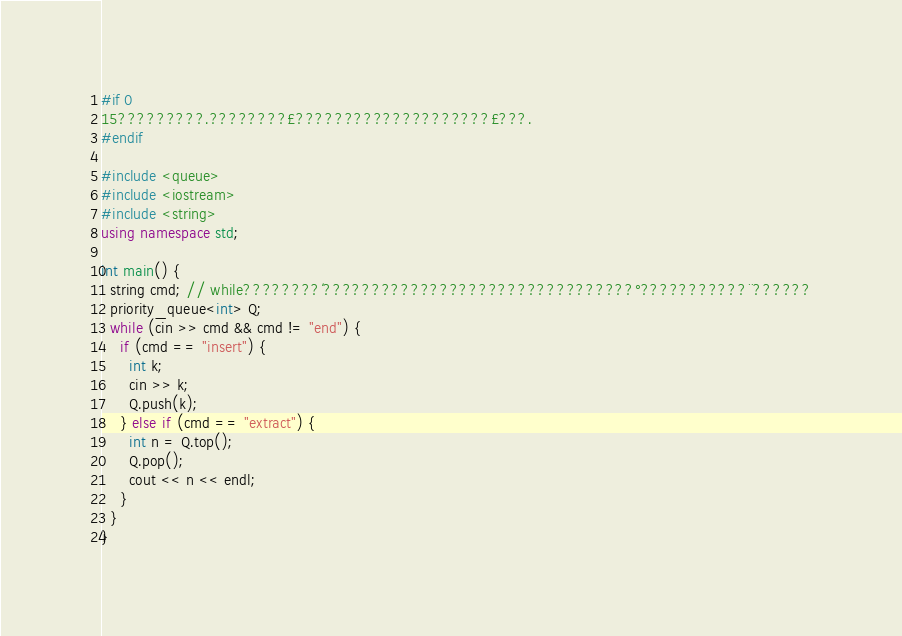Convert code to text. <code><loc_0><loc_0><loc_500><loc_500><_C++_>#if 0
15?????????.????????£????????????????????£???.
#endif

#include <queue>
#include <iostream>
#include <string>
using namespace std;

int main() {
  string cmd; // while????????´????????????????????????????????°???????????¨??????
  priority_queue<int> Q;
  while (cin >> cmd && cmd != "end") {
    if (cmd == "insert") {
      int k;
      cin >> k;
      Q.push(k);
    } else if (cmd == "extract") {
      int n = Q.top();
      Q.pop();
      cout << n << endl;
    }
  }
}</code> 